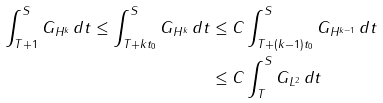Convert formula to latex. <formula><loc_0><loc_0><loc_500><loc_500>\int _ { T + 1 } ^ { S } \| G \| _ { H ^ { k } } \, d t \leq \int _ { T + k t _ { 0 } } ^ { S } \| G \| _ { H ^ { k } } \, d t & \leq C \int _ { T + ( k - 1 ) t _ { 0 } } ^ { S } \| G \| _ { H ^ { k - 1 } } \, d t \\ & \leq C \int _ { T } ^ { S } \| G \| _ { L ^ { 2 } } \, d t</formula> 